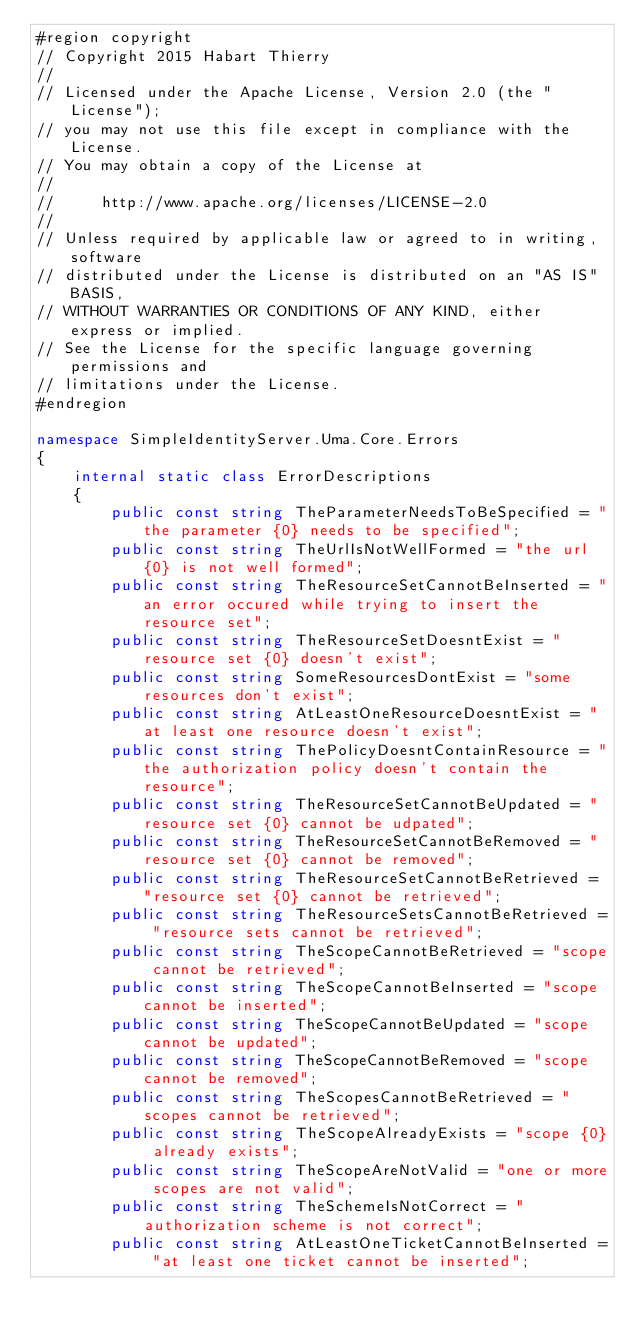<code> <loc_0><loc_0><loc_500><loc_500><_C#_>#region copyright
// Copyright 2015 Habart Thierry
// 
// Licensed under the Apache License, Version 2.0 (the "License");
// you may not use this file except in compliance with the License.
// You may obtain a copy of the License at
// 
//     http://www.apache.org/licenses/LICENSE-2.0
// 
// Unless required by applicable law or agreed to in writing, software
// distributed under the License is distributed on an "AS IS" BASIS,
// WITHOUT WARRANTIES OR CONDITIONS OF ANY KIND, either express or implied.
// See the License for the specific language governing permissions and
// limitations under the License.
#endregion

namespace SimpleIdentityServer.Uma.Core.Errors
{
    internal static class ErrorDescriptions
    {
        public const string TheParameterNeedsToBeSpecified = "the parameter {0} needs to be specified";           
        public const string TheUrlIsNotWellFormed = "the url {0} is not well formed";
        public const string TheResourceSetCannotBeInserted = "an error occured while trying to insert the resource set";
        public const string TheResourceSetDoesntExist = "resource set {0} doesn't exist";
        public const string SomeResourcesDontExist = "some resources don't exist";
        public const string AtLeastOneResourceDoesntExist = "at least one resource doesn't exist";
        public const string ThePolicyDoesntContainResource = "the authorization policy doesn't contain the resource";
        public const string TheResourceSetCannotBeUpdated = "resource set {0} cannot be udpated";
        public const string TheResourceSetCannotBeRemoved = "resource set {0} cannot be removed";
        public const string TheResourceSetCannotBeRetrieved = "resource set {0} cannot be retrieved";
        public const string TheResourceSetsCannotBeRetrieved = "resource sets cannot be retrieved";
        public const string TheScopeCannotBeRetrieved = "scope cannot be retrieved";
        public const string TheScopeCannotBeInserted = "scope cannot be inserted";
        public const string TheScopeCannotBeUpdated = "scope cannot be updated";
        public const string TheScopeCannotBeRemoved = "scope cannot be removed";
        public const string TheScopesCannotBeRetrieved = "scopes cannot be retrieved";
        public const string TheScopeAlreadyExists = "scope {0} already exists";
        public const string TheScopeAreNotValid = "one or more scopes are not valid";
        public const string TheSchemeIsNotCorrect = "authorization scheme is not correct";
        public const string AtLeastOneTicketCannotBeInserted = "at least one ticket cannot be inserted";</code> 